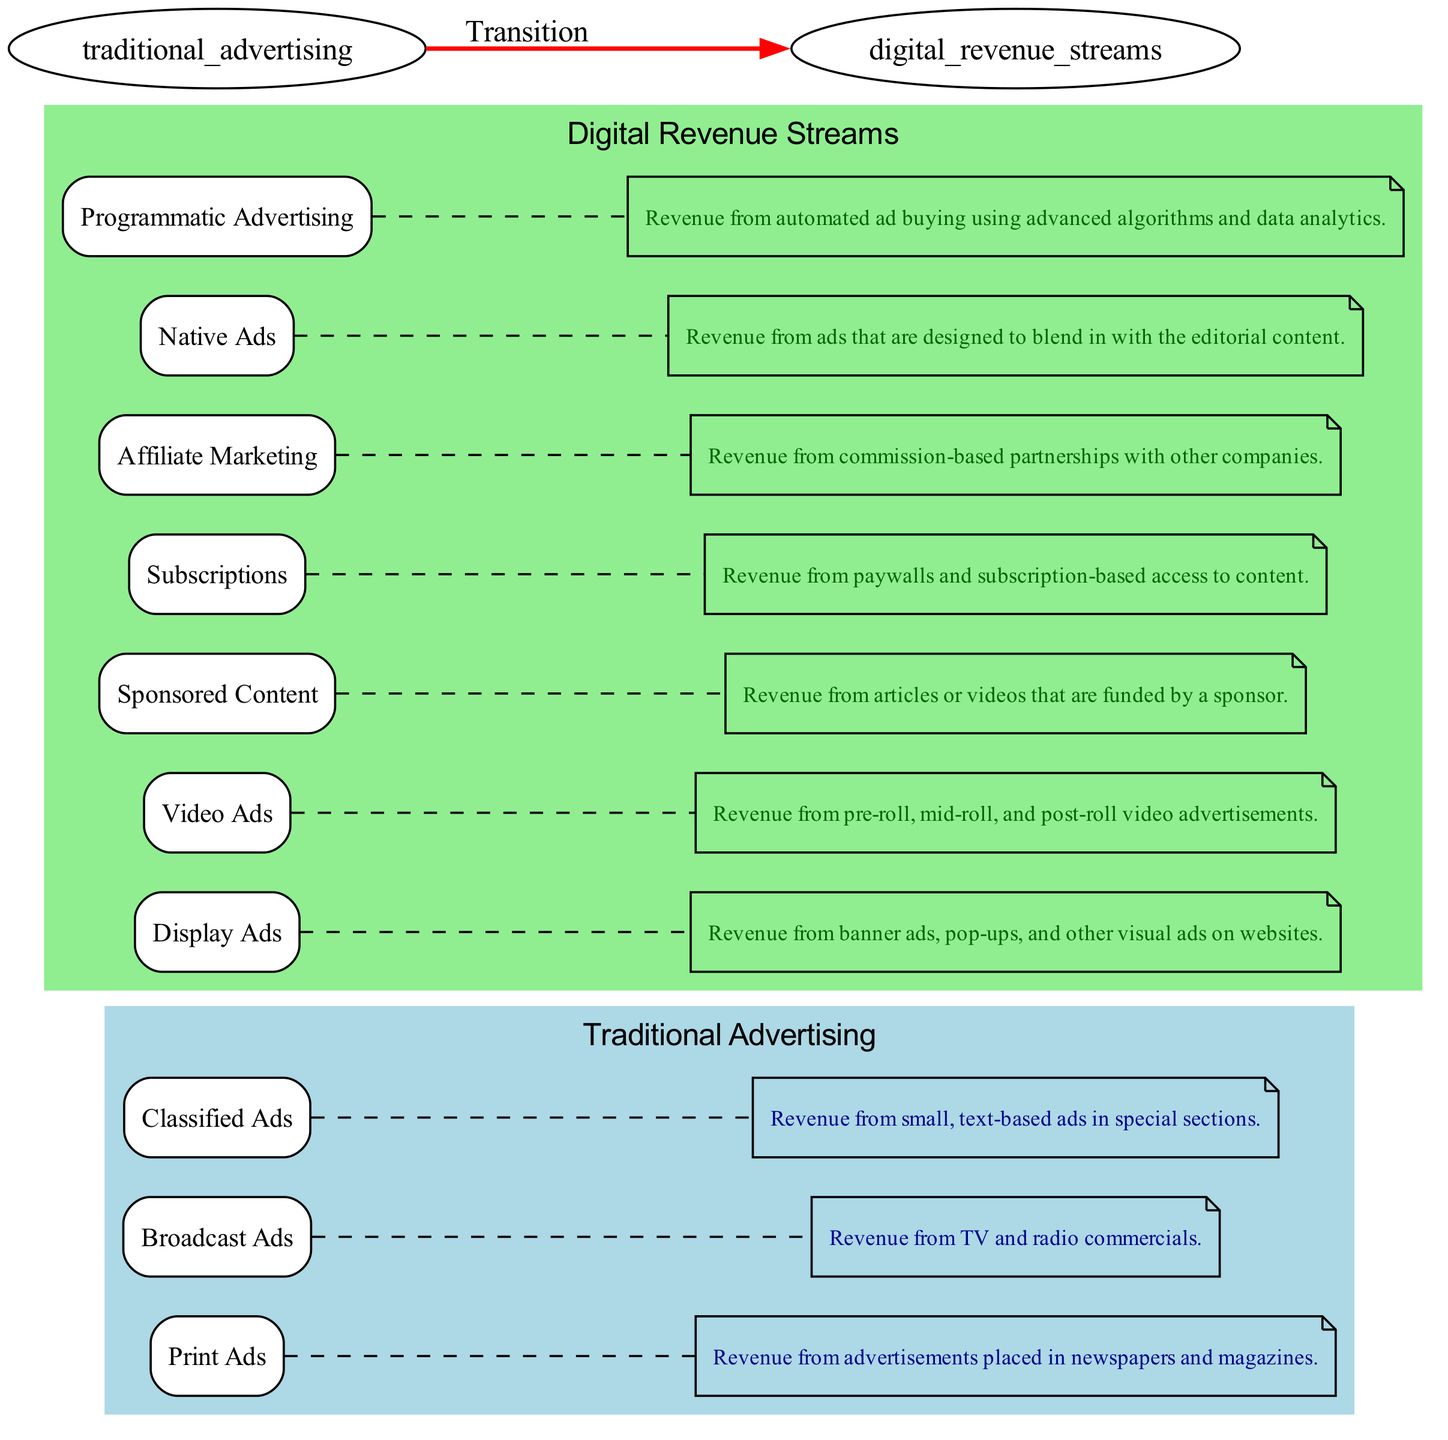What are the three subsections of Traditional Advertising? Traditional Advertising has three subsections listed in the diagram: Print Ads, Broadcast Ads, and Classified Ads.
Answer: Print Ads, Broadcast Ads, Classified Ads How many subsections does Digital Revenue Streams have? The diagram illustrates seven subsections under Digital Revenue Streams: Display Ads, Video Ads, Sponsored Content, Subscriptions, Affiliate Marketing, Native Ads, and Programmatic Advertising.
Answer: Seven What color is used to represent Digital Revenue Streams in the diagram? The Digital Revenue Streams cluster in the diagram is filled with a light green color as indicated in the graph attributes.
Answer: Light green Which type of ad is described as revenue from banner ads on websites? In the digital revenue streams section, Display Ads are specifically defined as revenue from banner ads, pop-ups, and other visual ads on websites.
Answer: Display Ads What connection type is used to describe the transition from Traditional Advertising to Digital Revenue Streams? The diagram employs a bold red edge to signify the transition between Traditional Advertising and Digital Revenue Streams, indicating a strong change in focus and strategy.
Answer: Transition Which subsection of Digital Revenue Streams provides revenue from paywalls? The Subscriptions subsection is noted in the diagram as the source of revenue generated from paywalls and subscription-based access to content.
Answer: Subscriptions What is the role of Native Ads in the Digital Revenue Streams? According to the diagram, Native Ads are defined as revenue from advertisements designed to blend in with editorial content, emphasizing a seamless user experience.
Answer: Revenue from ads that blend in with editorial content How are details related to each advertising type represented in the diagram? Each advertising type has an additional note connected to it with a dashed edge, providing a detailed description of the revenue source, thus enhancing the visual explanation of the data.
Answer: Dashed note connections Which subsection of Traditional Advertising generates revenue from small, text-based ads? Classified Ads is identified in the diagram as the subsection of Traditional Advertising that focuses on revenue from small, text-based advertisements typically found in specialized sections.
Answer: Classified Ads 